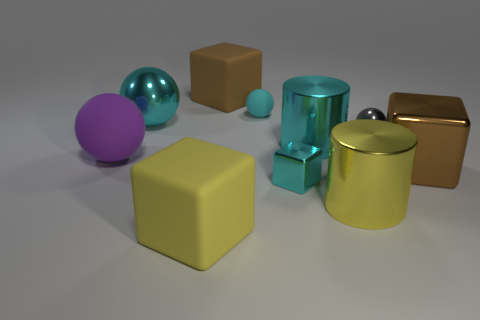Is the size of the yellow matte cube that is in front of the gray object the same as the cyan shiny sphere?
Provide a succinct answer. Yes. What number of small things are either cyan balls or gray shiny objects?
Your response must be concise. 2. Are there any tiny metal objects that have the same color as the big rubber ball?
Your answer should be very brief. No. The other yellow thing that is the same size as the yellow matte thing is what shape?
Offer a very short reply. Cylinder. Do the matte cube behind the large yellow cube and the tiny block have the same color?
Your response must be concise. No. What number of things are either large matte objects behind the tiny cyan cube or small purple matte spheres?
Provide a short and direct response. 2. Are there more large rubber balls that are right of the yellow metallic cylinder than gray things left of the small gray shiny object?
Offer a terse response. No. Is the material of the yellow cylinder the same as the large cyan ball?
Your response must be concise. Yes. There is a matte object that is both to the right of the big yellow matte thing and to the left of the cyan rubber object; what is its shape?
Your answer should be compact. Cube. The big brown object that is made of the same material as the purple object is what shape?
Keep it short and to the point. Cube. 